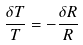Convert formula to latex. <formula><loc_0><loc_0><loc_500><loc_500>\frac { { \delta } T } { T } = - \frac { { \delta } R } { R }</formula> 